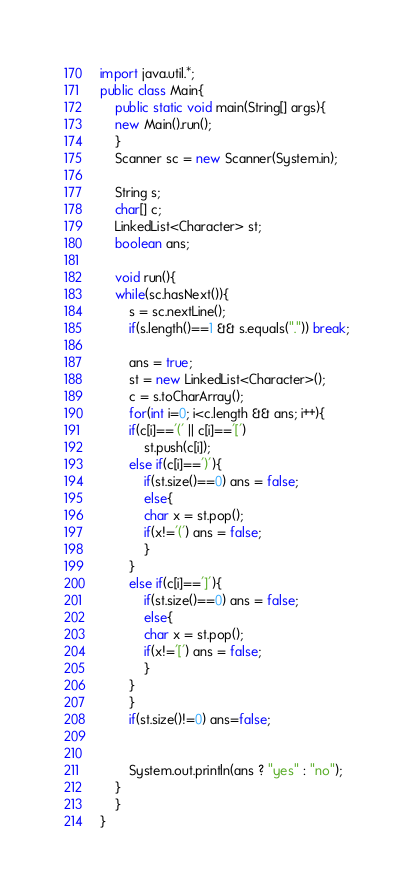Convert code to text. <code><loc_0><loc_0><loc_500><loc_500><_Java_>import java.util.*;
public class Main{
    public static void main(String[] args){
	new Main().run();
    }
    Scanner sc = new Scanner(System.in);

    String s;
    char[] c;
    LinkedList<Character> st;
    boolean ans;

    void run(){
	while(sc.hasNext()){
	    s = sc.nextLine();
	    if(s.length()==1 && s.equals(".")) break;

	    ans = true;
	    st = new LinkedList<Character>();
	    c = s.toCharArray();
	    for(int i=0; i<c.length && ans; i++){
		if(c[i]=='(' || c[i]=='[')
		    st.push(c[i]);
		else if(c[i]==')'){
		    if(st.size()==0) ans = false;
		    else{
			char x = st.pop();
			if(x!='(') ans = false;
		    }
		}
		else if(c[i]==']'){
		    if(st.size()==0) ans = false;
		    else{
			char x = st.pop();
			if(x!='[') ans = false;
		    }
		}
	    }
	    if(st.size()!=0) ans=false;


	    System.out.println(ans ? "yes" : "no");
	}
    }
}</code> 